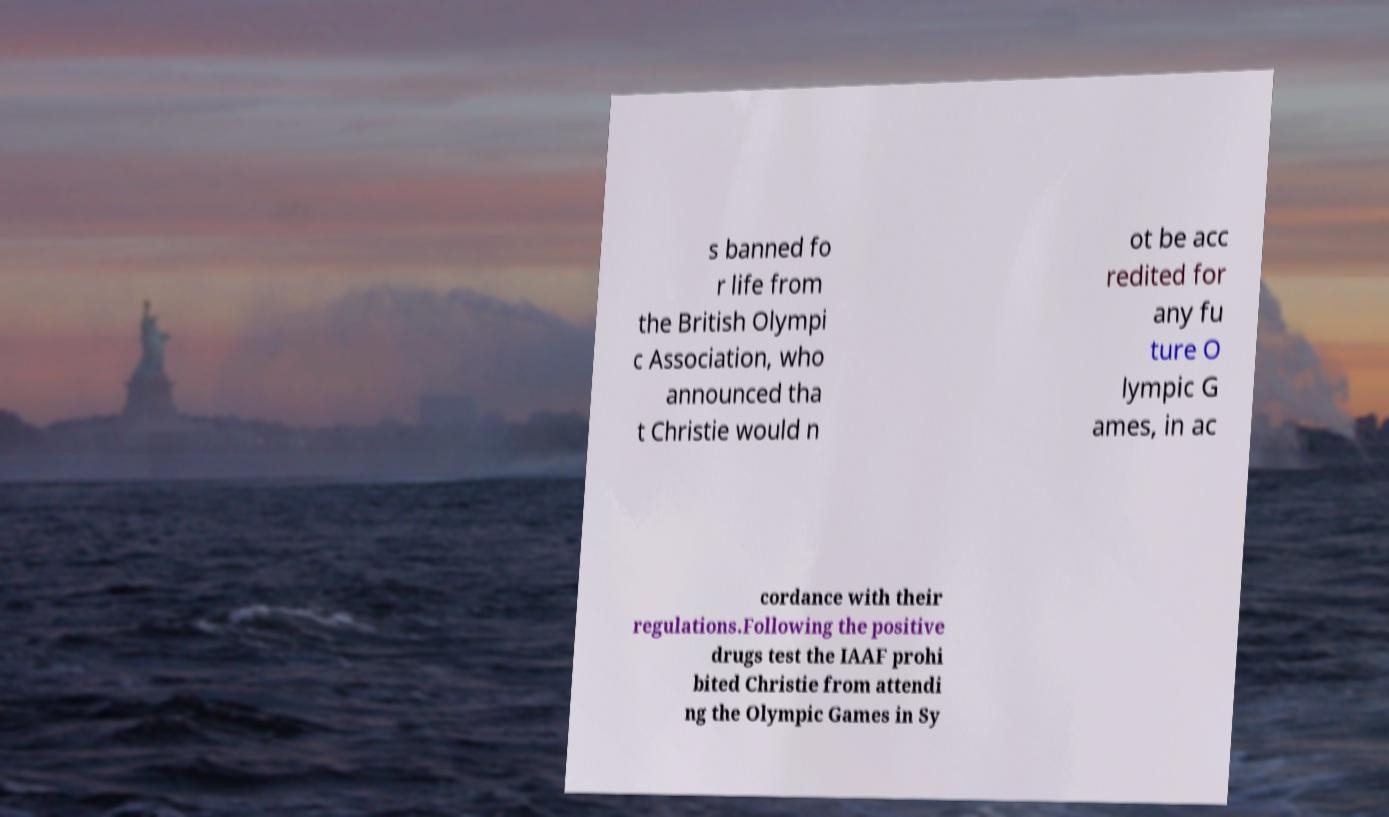For documentation purposes, I need the text within this image transcribed. Could you provide that? s banned fo r life from the British Olympi c Association, who announced tha t Christie would n ot be acc redited for any fu ture O lympic G ames, in ac cordance with their regulations.Following the positive drugs test the IAAF prohi bited Christie from attendi ng the Olympic Games in Sy 